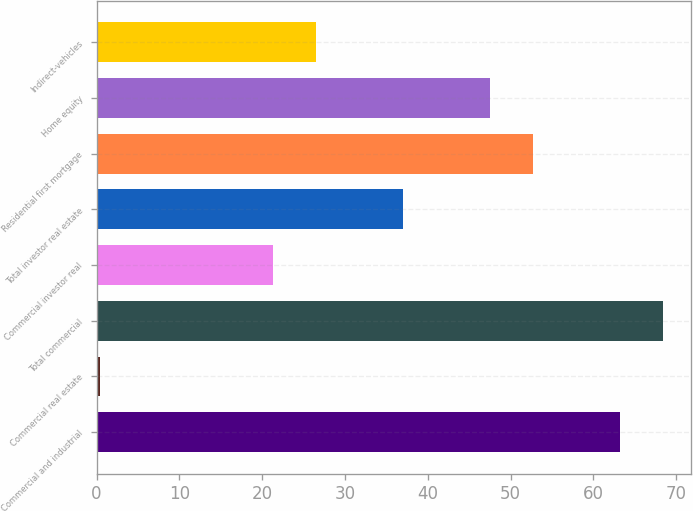Convert chart. <chart><loc_0><loc_0><loc_500><loc_500><bar_chart><fcel>Commercial and industrial<fcel>Commercial real estate<fcel>Total commercial<fcel>Commercial investor real<fcel>Total investor real estate<fcel>Residential first mortgage<fcel>Home equity<fcel>Indirect-vehicles<nl><fcel>63.16<fcel>0.4<fcel>68.39<fcel>21.32<fcel>37.01<fcel>52.7<fcel>47.47<fcel>26.55<nl></chart> 